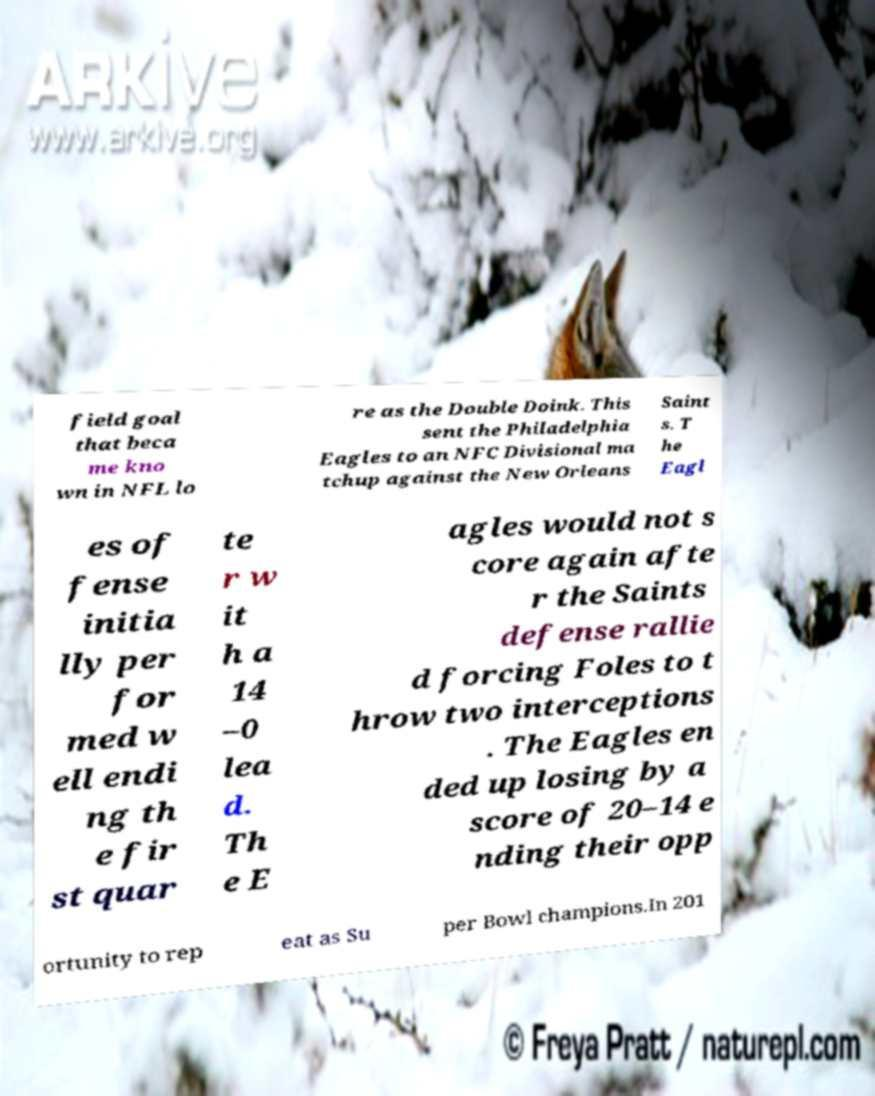Please read and relay the text visible in this image. What does it say? field goal that beca me kno wn in NFL lo re as the Double Doink. This sent the Philadelphia Eagles to an NFC Divisional ma tchup against the New Orleans Saint s. T he Eagl es of fense initia lly per for med w ell endi ng th e fir st quar te r w it h a 14 –0 lea d. Th e E agles would not s core again afte r the Saints defense rallie d forcing Foles to t hrow two interceptions . The Eagles en ded up losing by a score of 20–14 e nding their opp ortunity to rep eat as Su per Bowl champions.In 201 